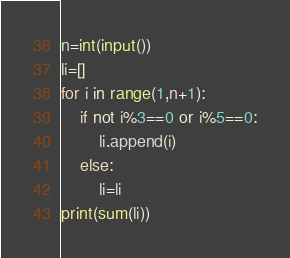<code> <loc_0><loc_0><loc_500><loc_500><_Python_>n=int(input())
li=[]
for i in range(1,n+1):
    if not i%3==0 or i%5==0:
        li.append(i)
    else:
        li=li
print(sum(li))</code> 